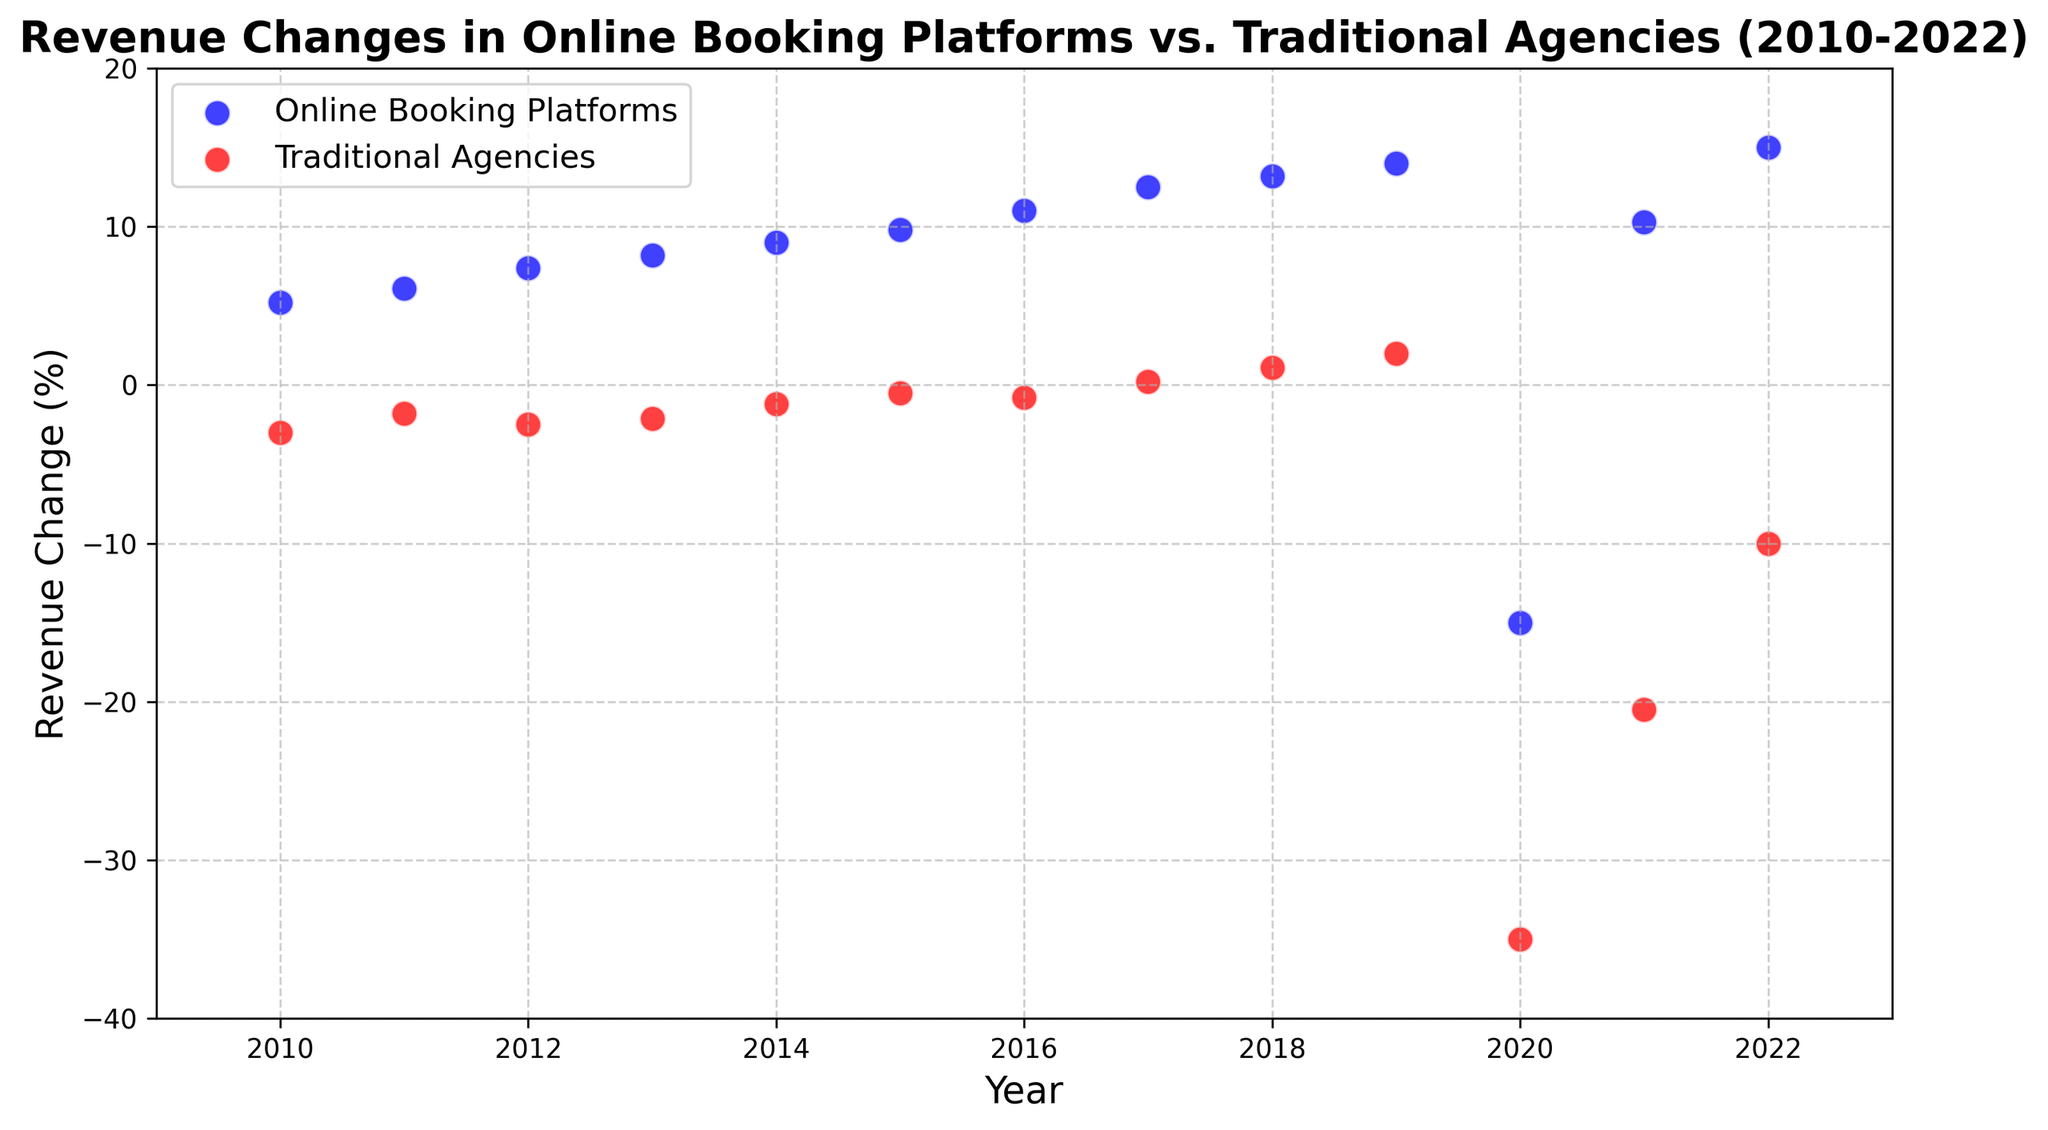What was the revenue change for online booking platforms in 2020? Look at the value on the y-axis for the blue scatter point in 2020.
Answer: -15.0% What was the revenue change for traditional agencies in 2020? Look at the value on the y-axis for the red scatter point in 2020.
Answer: -35.0% Which year did traditional agencies first show positive revenue change? Identify the first red scatter point above the 0% revenue change line on the y-axis.
Answer: 2017 Which year had the largest positive revenue change for online booking platforms? Identify the highest blue scatter point on the plot.
Answer: 2022 In which year did both online booking platforms and traditional agencies show negative revenue changes? Look for a year where both the blue and red scatter points are below the 0% revenue change line on the y-axis.
Answer: 2020 How did the revenue change for traditional agencies in 2021 compare to 2020? Compare the position of the red scatter point in 2021 to its position in 2020 on the y-axis.
Answer: It improved How many years did online booking platforms have negative revenue change? Count the number of blue scatter points below the 0% revenue change line on the y-axis.
Answer: 1 year What is the general trend for online booking platforms' revenue change from 2010 to 2022? Observe the overall direction of the blue scatter points from 2010 to 2022.
Answer: Increasing, except for a dip in 2020 What is the difference in revenue change between online booking platforms and traditional agencies in 2014? Subtract the revenue change for traditional agencies from the revenue change for online booking platforms for the year 2014.
Answer: 9.0% - (-1.2%) = 10.2% Calculate the average revenue change for traditional agencies from 2010 to 2019. Sum the revenue changes for traditional agencies from 2010 to 2019 and then divide by the number of years.
Answer: (-3.0 + (-1.8) + (-2.5) + (-2.1) + (-1.2) + (-0.5) + (-0.8) + 0.2 + 1.1 + 2.0) / 10 = -0.46% 